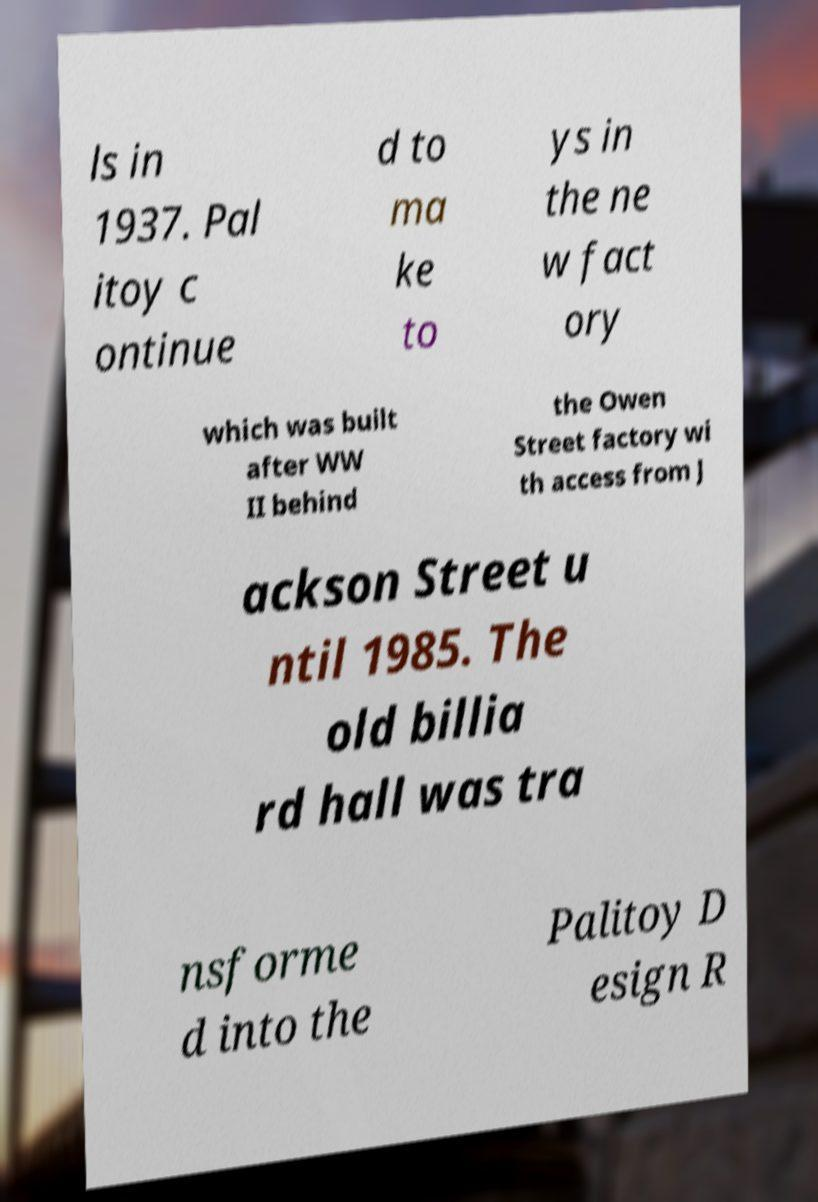Please identify and transcribe the text found in this image. ls in 1937. Pal itoy c ontinue d to ma ke to ys in the ne w fact ory which was built after WW II behind the Owen Street factory wi th access from J ackson Street u ntil 1985. The old billia rd hall was tra nsforme d into the Palitoy D esign R 